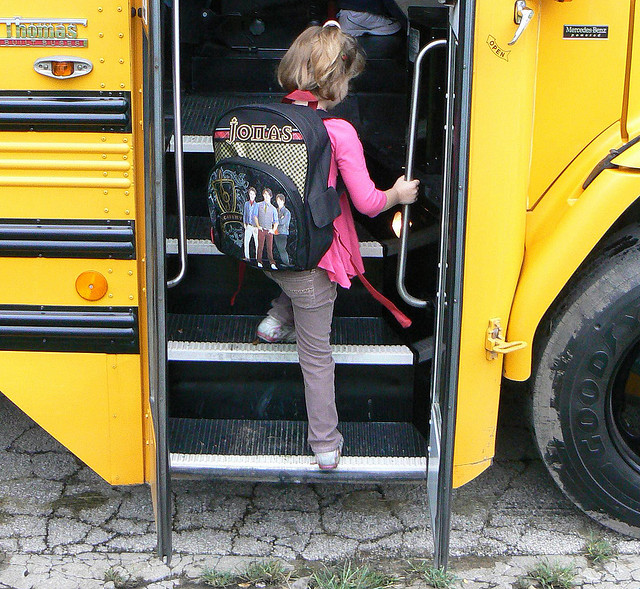Please extract the text content from this image. jonas Thomas OPEN 